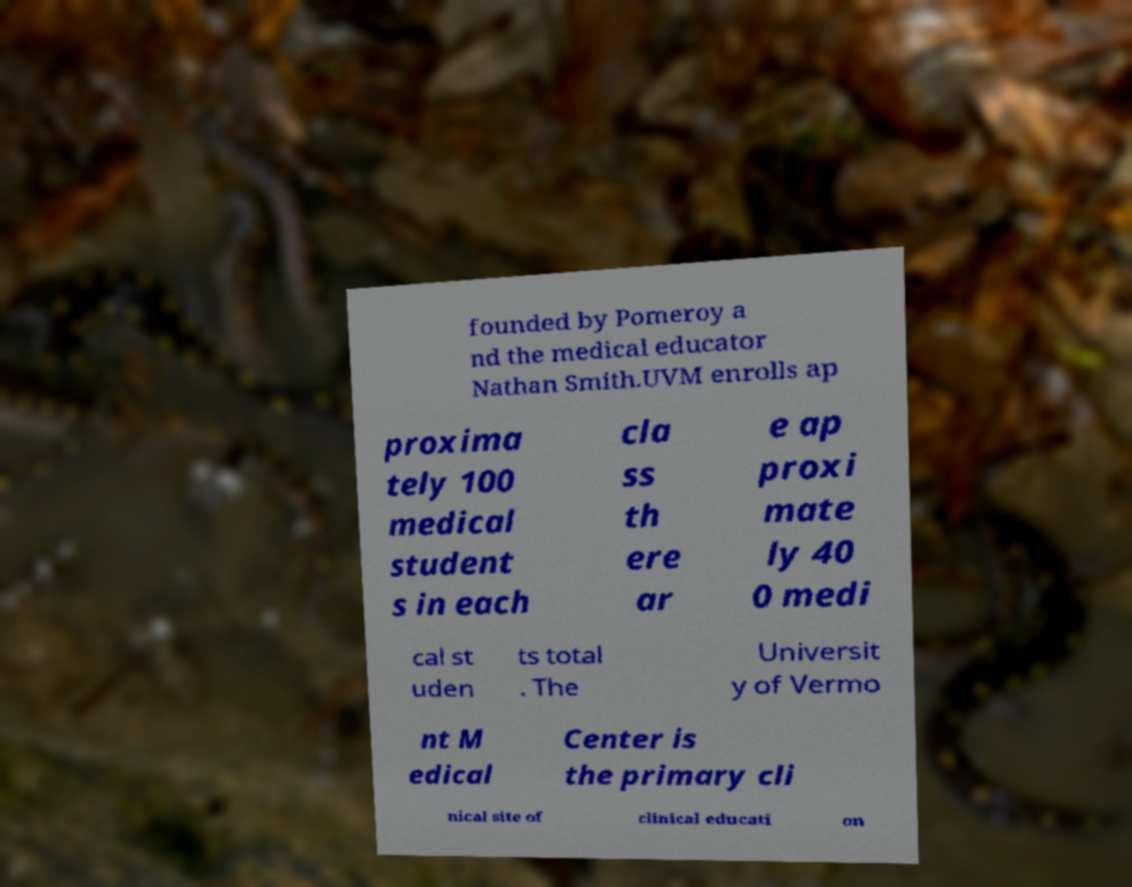Please identify and transcribe the text found in this image. founded by Pomeroy a nd the medical educator Nathan Smith.UVM enrolls ap proxima tely 100 medical student s in each cla ss th ere ar e ap proxi mate ly 40 0 medi cal st uden ts total . The Universit y of Vermo nt M edical Center is the primary cli nical site of clinical educati on 